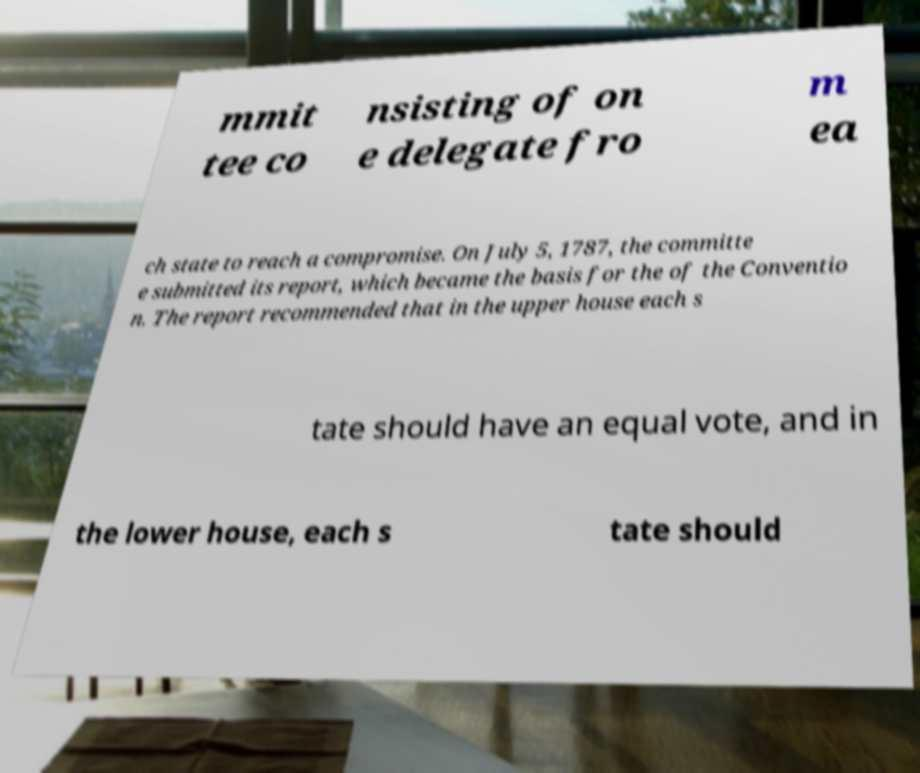Could you assist in decoding the text presented in this image and type it out clearly? mmit tee co nsisting of on e delegate fro m ea ch state to reach a compromise. On July 5, 1787, the committe e submitted its report, which became the basis for the of the Conventio n. The report recommended that in the upper house each s tate should have an equal vote, and in the lower house, each s tate should 